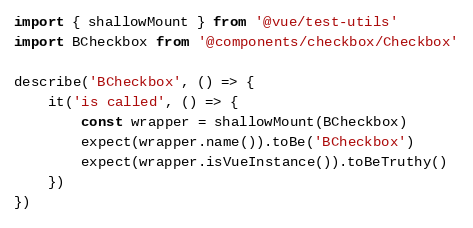<code> <loc_0><loc_0><loc_500><loc_500><_JavaScript_>import { shallowMount } from '@vue/test-utils'
import BCheckbox from '@components/checkbox/Checkbox'

describe('BCheckbox', () => {
    it('is called', () => {
        const wrapper = shallowMount(BCheckbox)
        expect(wrapper.name()).toBe('BCheckbox')
        expect(wrapper.isVueInstance()).toBeTruthy()
    })
})
</code> 